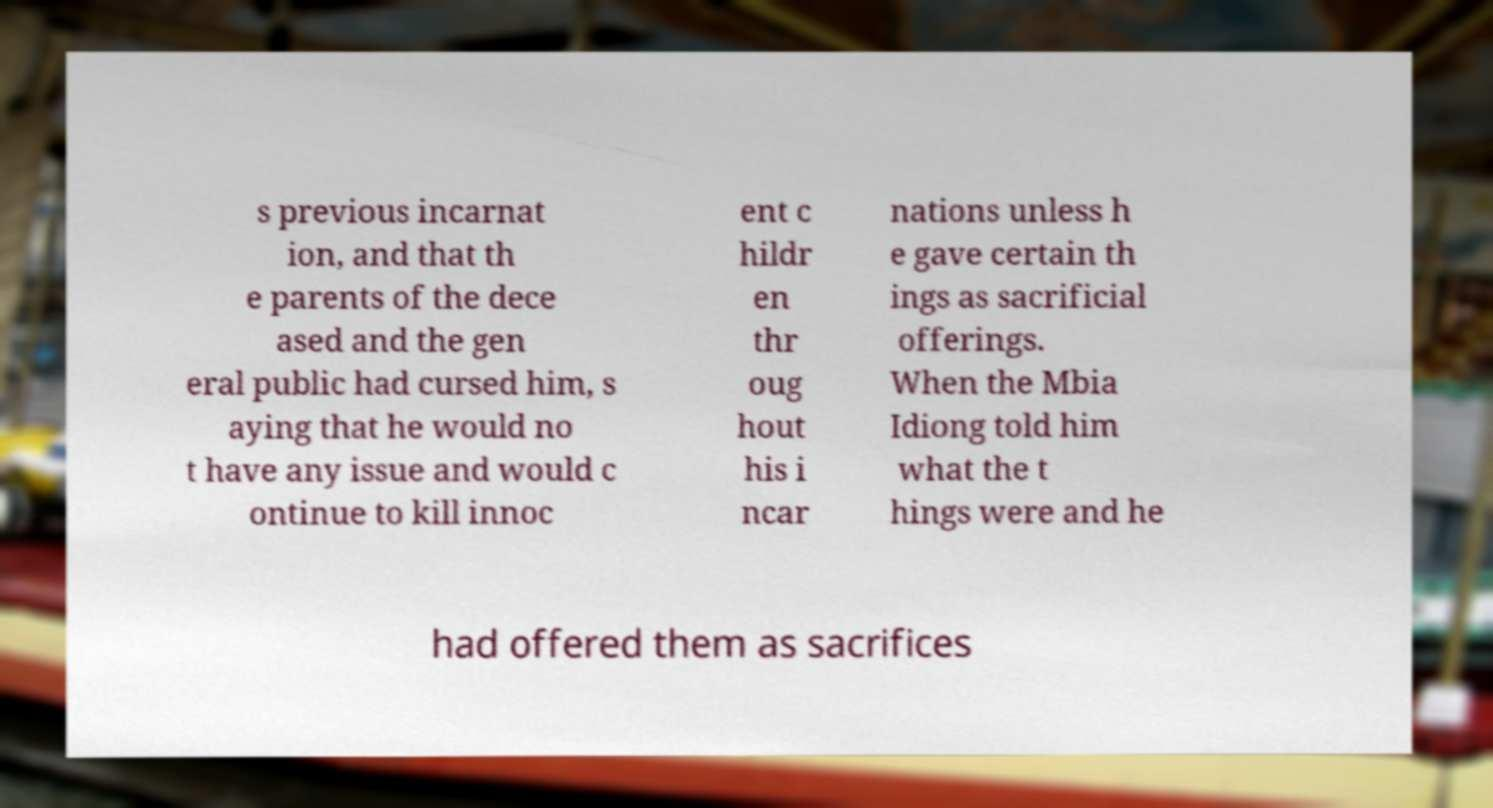I need the written content from this picture converted into text. Can you do that? s previous incarnat ion, and that th e parents of the dece ased and the gen eral public had cursed him, s aying that he would no t have any issue and would c ontinue to kill innoc ent c hildr en thr oug hout his i ncar nations unless h e gave certain th ings as sacrificial offerings. When the Mbia Idiong told him what the t hings were and he had offered them as sacrifices 